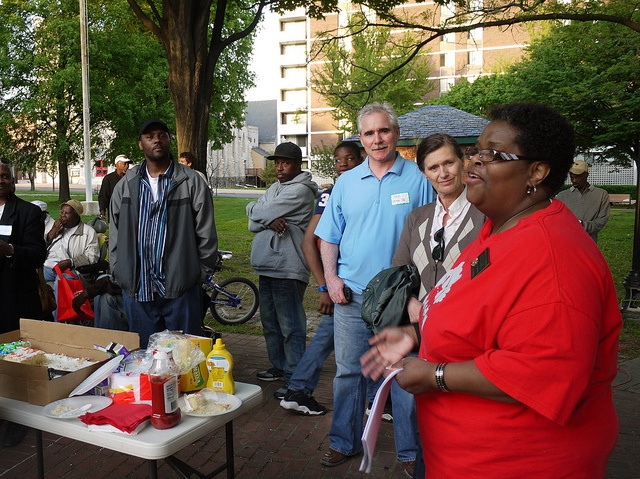Describe the objects in this image and their specific colors. I can see people in white, brown, maroon, and black tones, dining table in white, darkgray, black, tan, and gray tones, people in white, lightblue, navy, and black tones, people in white, black, gray, and darkblue tones, and people in white, black, gray, and darkgray tones in this image. 